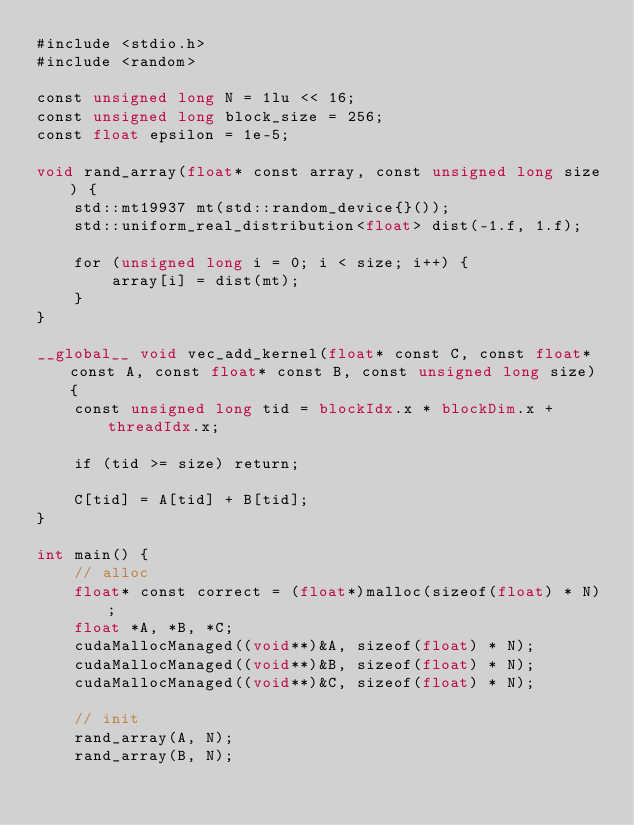Convert code to text. <code><loc_0><loc_0><loc_500><loc_500><_Cuda_>#include <stdio.h>
#include <random>

const unsigned long N = 1lu << 16;
const unsigned long block_size = 256;
const float epsilon = 1e-5;

void rand_array(float* const array, const unsigned long size) {
	std::mt19937 mt(std::random_device{}());
	std::uniform_real_distribution<float> dist(-1.f, 1.f);

	for (unsigned long i = 0; i < size; i++) {
		array[i] = dist(mt);
	}
}

__global__ void vec_add_kernel(float* const C, const float* const A, const float* const B, const unsigned long size) {
	const unsigned long tid = blockIdx.x * blockDim.x + threadIdx.x;

	if (tid >= size) return;

	C[tid] = A[tid] + B[tid];
}

int main() {
	// alloc
	float* const correct = (float*)malloc(sizeof(float) * N);
	float *A, *B, *C;
	cudaMallocManaged((void**)&A, sizeof(float) * N);
	cudaMallocManaged((void**)&B, sizeof(float) * N);
	cudaMallocManaged((void**)&C, sizeof(float) * N);

	// init
	rand_array(A, N);
	rand_array(B, N);</code> 